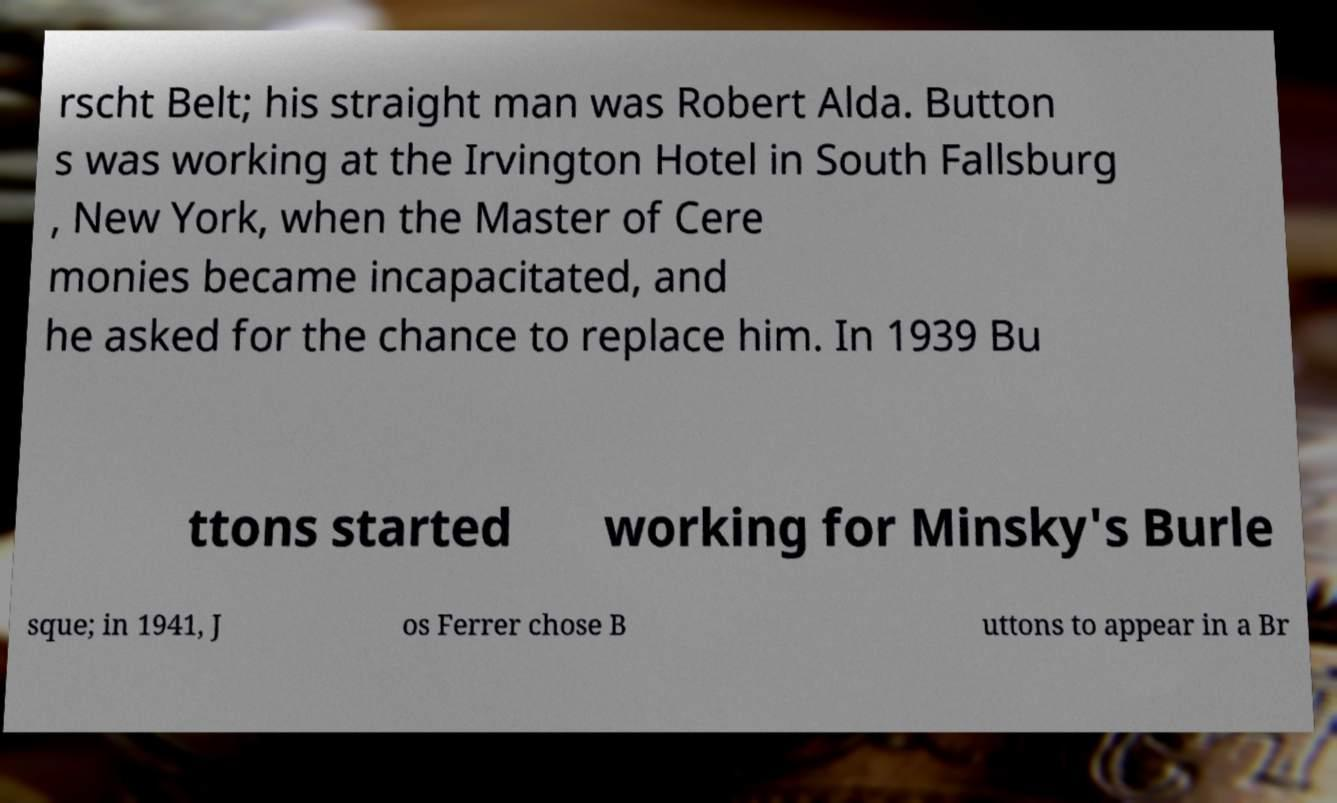Could you extract and type out the text from this image? rscht Belt; his straight man was Robert Alda. Button s was working at the Irvington Hotel in South Fallsburg , New York, when the Master of Cere monies became incapacitated, and he asked for the chance to replace him. In 1939 Bu ttons started working for Minsky's Burle sque; in 1941, J os Ferrer chose B uttons to appear in a Br 